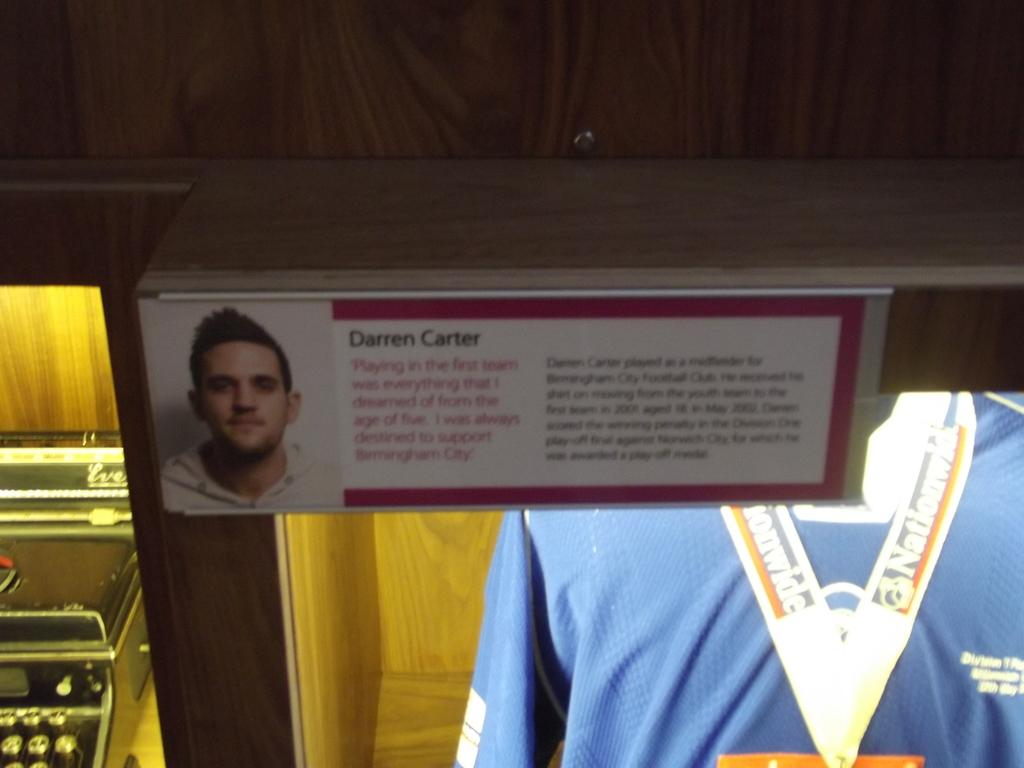<image>
Provide a brief description of the given image. Darren Carter is shown on a photo next to a jersey 